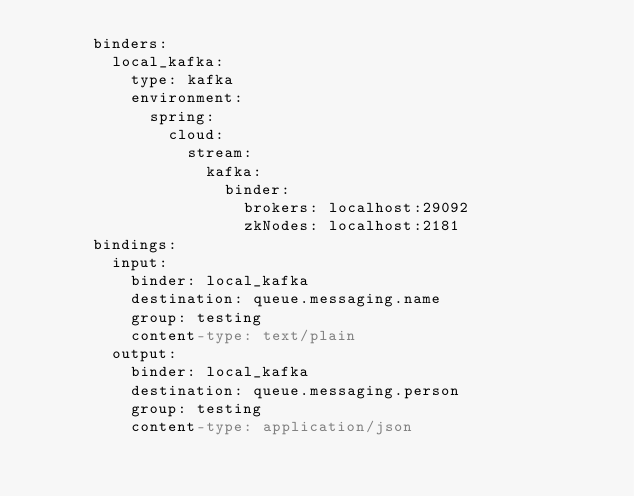<code> <loc_0><loc_0><loc_500><loc_500><_YAML_>      binders:
        local_kafka:
          type: kafka
          environment:
            spring:
              cloud:
                stream:
                  kafka:
                    binder:
                      brokers: localhost:29092
                      zkNodes: localhost:2181
      bindings:
        input:
          binder: local_kafka
          destination: queue.messaging.name
          group: testing
          content-type: text/plain
        output:
          binder: local_kafka
          destination: queue.messaging.person
          group: testing
          content-type: application/json

</code> 